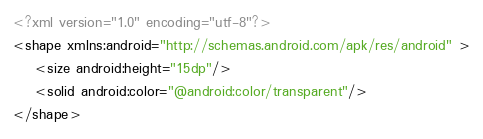<code> <loc_0><loc_0><loc_500><loc_500><_XML_><?xml version="1.0" encoding="utf-8"?>
<shape xmlns:android="http://schemas.android.com/apk/res/android" >
    <size android:height="15dp"/>
    <solid android:color="@android:color/transparent"/>
</shape></code> 